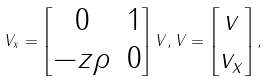<formula> <loc_0><loc_0><loc_500><loc_500>V _ { x } = \begin{bmatrix} 0 & 1 \\ - z \rho & 0 \end{bmatrix} V , V = \begin{bmatrix} v \\ v _ { x } \end{bmatrix} ,</formula> 